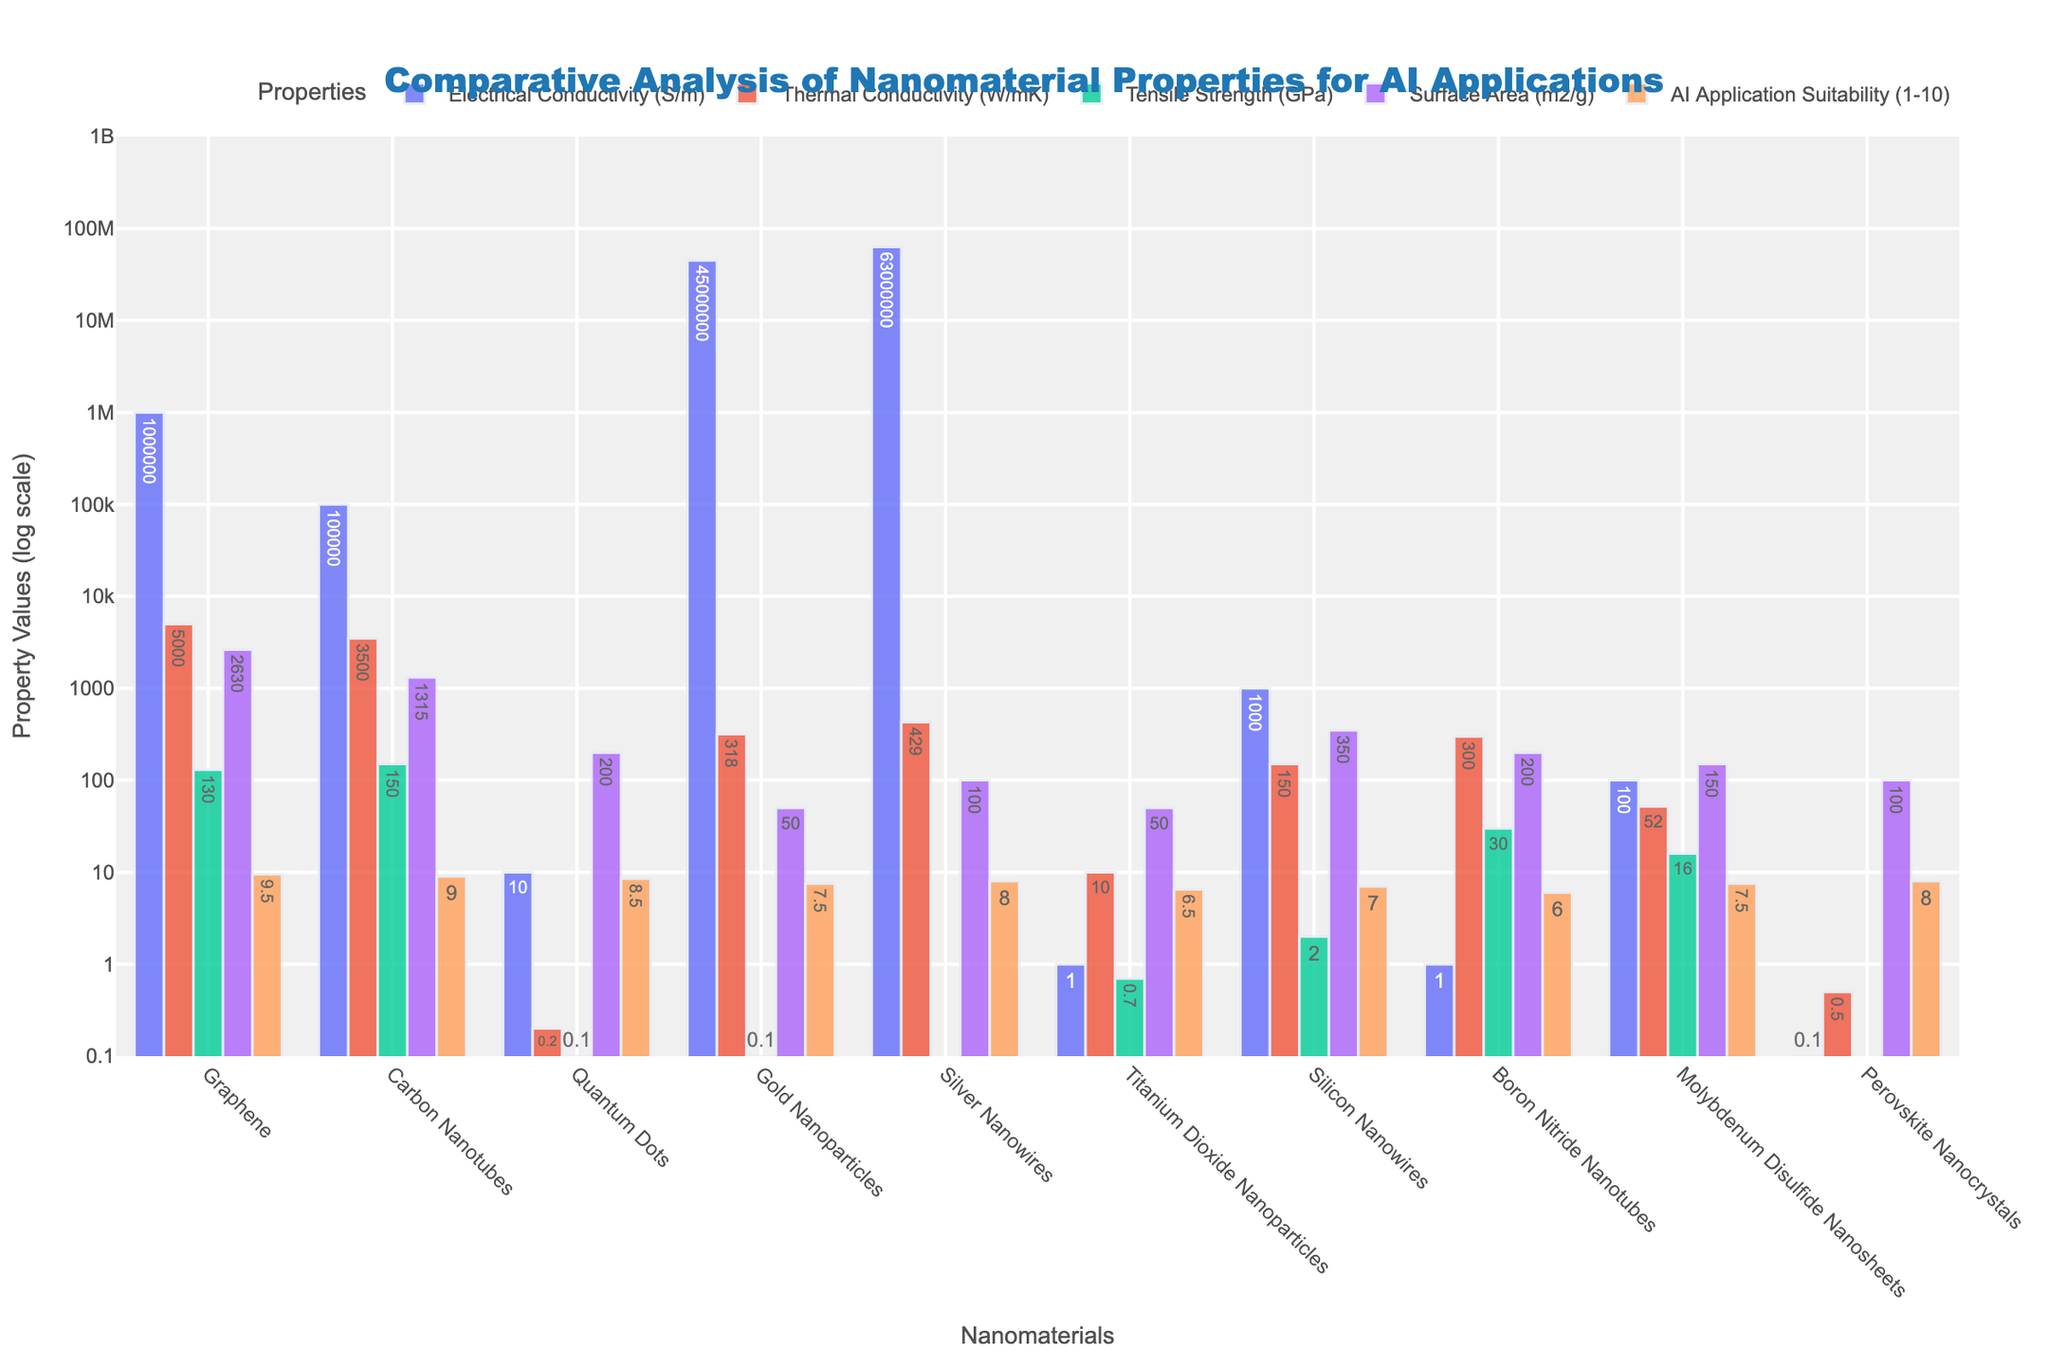What material has the highest electrical conductivity? By looking at the bar graph and focusing on the bars representing "Electrical Conductivity (S/m)," we identify the longest bar, which corresponds to Silver Nanowires.
Answer: Silver Nanowires Which material has the smallest tensile strength, and what is its value? By looking at the bars representing "Tensile Strength (GPa)," the shortest bar corresponds to Perovskite Nanocrystals with a value of 0.05 GPa.
Answer: Perovskite Nanocrystals, 0.05 GPa How does the AI application suitability of Graphene compare to Carbon Nanotubes? By comparing the height of the bars for "AI Application Suitability (1-10)" between Graphene and Carbon Nanotubes, Graphene has a slightly higher value of 9.5 compared to Carbon Nanotubes' 9.0.
Answer: Graphene is higher What's the average thermal conductivity of the top three materials? The top three materials by thermal conductivity are Graphene (5000), Carbon Nanotubes (3500), and Silver Nanowires (429). The average is calculated as (5000 + 3500 + 429) / 3 = 2976.33.
Answer: 2976.33 Which nanomaterial has the largest surface area and what is its value? By examining the bars for "Surface Area (m2/g)," the highest bar corresponds to Graphene with a value of 2630 m²/g.
Answer: Graphene, 2630 m²/g What property makes Gold Nanoparticles less suitable for AI compared to Graphene despite their high electrical conductivity? Despite Gold Nanoparticles having high electrical conductivity (45000000 S/m), their tensile strength (0.1 GPa) and surface area (50 m²/g) are significantly lower than those of Graphene, affecting their overall suitability for AI applications.
Answer: Lower tensile strength and surface area Compare the thermal conductivity and tensile strength of Molybdenum Disulfide Nanosheets. Which is higher? Looking at the bars representing Molybdenum Disulfide Nanosheets, the bar for "Thermal Conductivity" is at 52 W/mK, and the bar for "Tensile Strength" is at 16 GPa. Therefore, the thermal conductivity is higher.
Answer: Thermal conductivity is higher Which material has the lowest AI application suitability, and what is its value? By identifying the shortest bar among the "AI Application Suitability (1-10)" values, Boron Nitride Nanotubes have the lowest suitability with a value of 6.0.
Answer: Boron Nitride Nanotubes, 6.0 